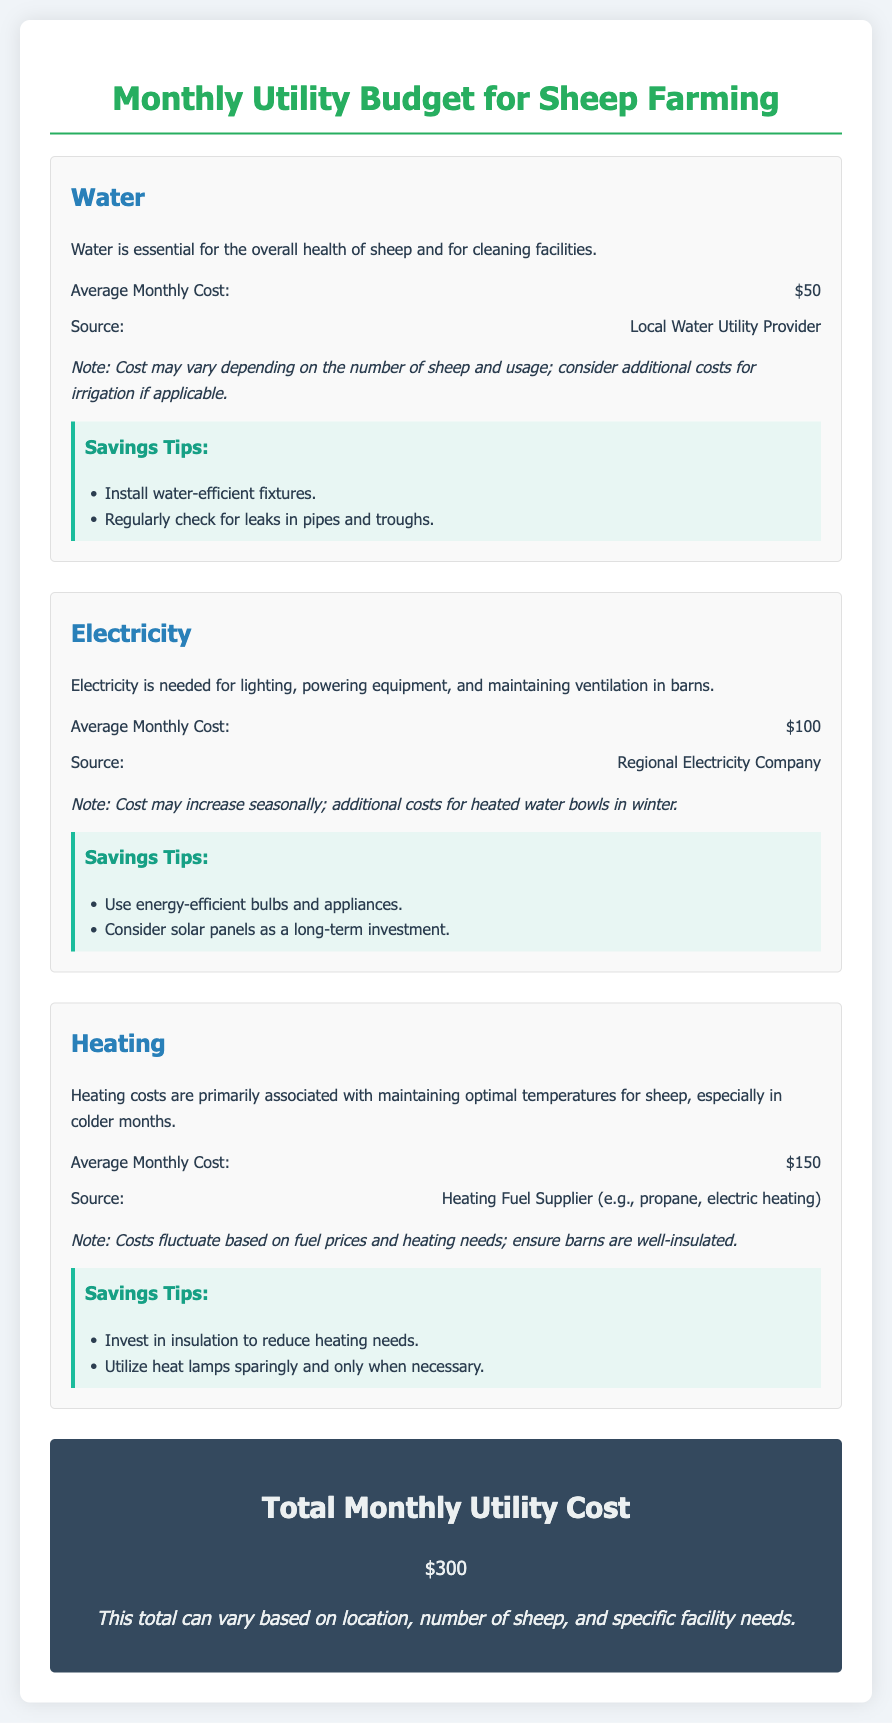What is the average monthly cost for water? The average monthly cost for water is provided in the document under the water section.
Answer: $50 What is the total monthly utility cost? The total monthly utility cost is the sum of all expenses, indicated at the end of the document.
Answer: $300 Which utility provider supplies electricity? The document specifies the source of electricity under the electricity section.
Answer: Regional Electricity Company What are two savings tips for water expenses? The savings tips for water expenses are listed in the water section of the document.
Answer: Install water-efficient fixtures, Check for leaks What is the average monthly heating cost? The heat expense section states the average monthly cost of heating.
Answer: $150 What is a suggested heating savings tip? The document provides savings tips specifically related to heating costs.
Answer: Invest in insulation to reduce heating needs How often might the electricity cost increase? The electricity section indicates when costs may increase based on specific conditions.
Answer: Seasonally What is noted about the water cost variability? The document mentions factors influencing water costs under the water section.
Answer: Depending on the number of sheep and usage 